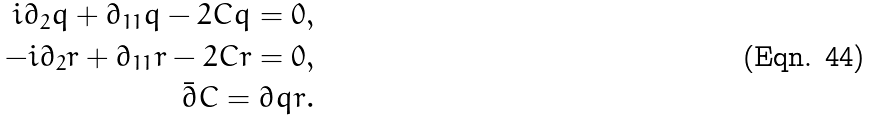Convert formula to latex. <formula><loc_0><loc_0><loc_500><loc_500>i \partial _ { 2 } q + \partial _ { 1 1 } q - 2 C q = 0 , \\ - i \partial _ { 2 } r + \partial _ { 1 1 } r - 2 C r = 0 , \\ \bar { \partial } C = \partial q r .</formula> 